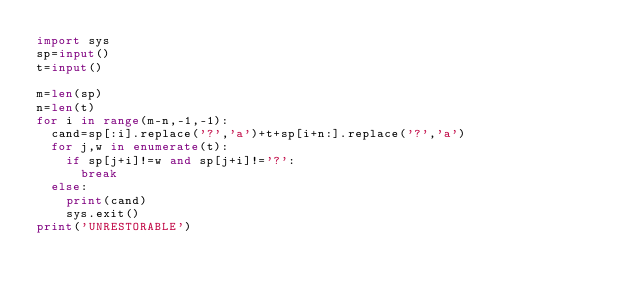Convert code to text. <code><loc_0><loc_0><loc_500><loc_500><_Python_>import sys
sp=input()
t=input()

m=len(sp)
n=len(t)
for i in range(m-n,-1,-1):
  cand=sp[:i].replace('?','a')+t+sp[i+n:].replace('?','a')
  for j,w in enumerate(t):
    if sp[j+i]!=w and sp[j+i]!='?':
      break
  else:
    print(cand)
    sys.exit()
print('UNRESTORABLE')</code> 